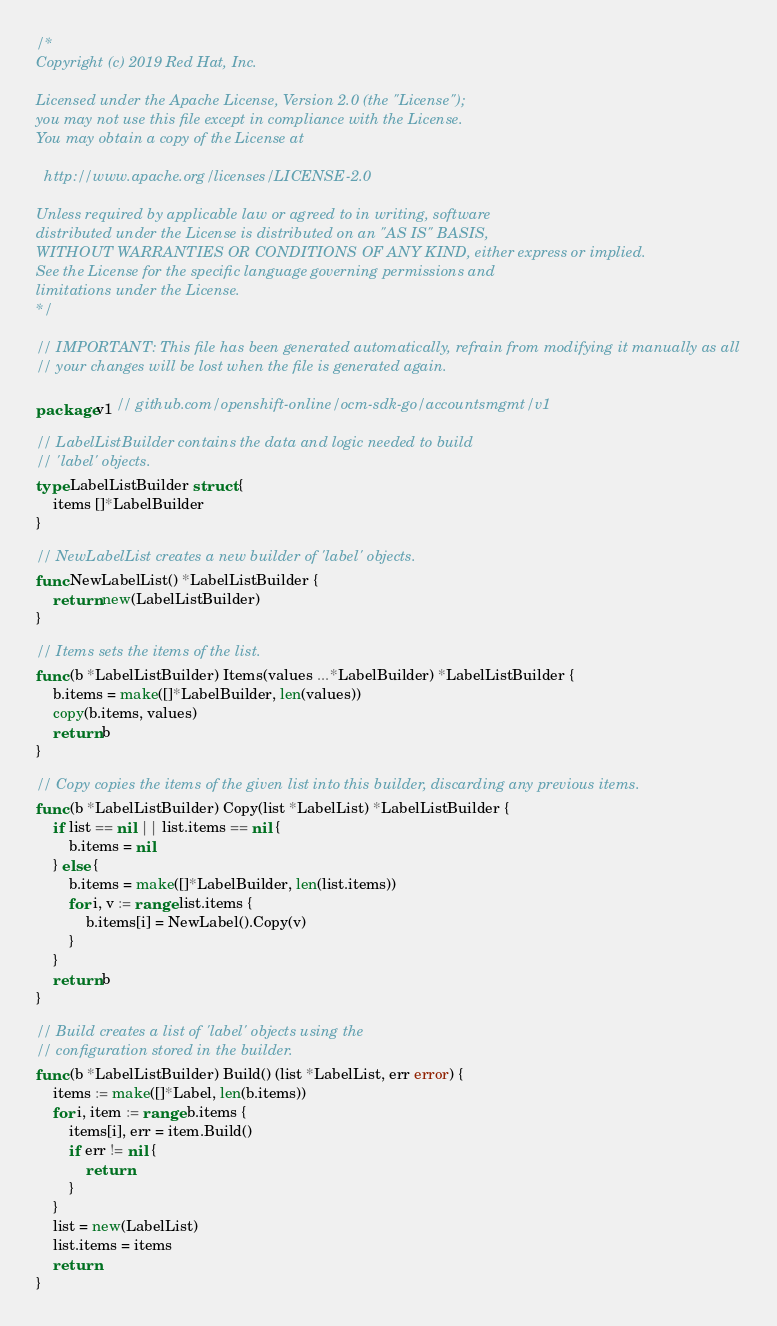Convert code to text. <code><loc_0><loc_0><loc_500><loc_500><_Go_>/*
Copyright (c) 2019 Red Hat, Inc.

Licensed under the Apache License, Version 2.0 (the "License");
you may not use this file except in compliance with the License.
You may obtain a copy of the License at

  http://www.apache.org/licenses/LICENSE-2.0

Unless required by applicable law or agreed to in writing, software
distributed under the License is distributed on an "AS IS" BASIS,
WITHOUT WARRANTIES OR CONDITIONS OF ANY KIND, either express or implied.
See the License for the specific language governing permissions and
limitations under the License.
*/

// IMPORTANT: This file has been generated automatically, refrain from modifying it manually as all
// your changes will be lost when the file is generated again.

package v1 // github.com/openshift-online/ocm-sdk-go/accountsmgmt/v1

// LabelListBuilder contains the data and logic needed to build
// 'label' objects.
type LabelListBuilder struct {
	items []*LabelBuilder
}

// NewLabelList creates a new builder of 'label' objects.
func NewLabelList() *LabelListBuilder {
	return new(LabelListBuilder)
}

// Items sets the items of the list.
func (b *LabelListBuilder) Items(values ...*LabelBuilder) *LabelListBuilder {
	b.items = make([]*LabelBuilder, len(values))
	copy(b.items, values)
	return b
}

// Copy copies the items of the given list into this builder, discarding any previous items.
func (b *LabelListBuilder) Copy(list *LabelList) *LabelListBuilder {
	if list == nil || list.items == nil {
		b.items = nil
	} else {
		b.items = make([]*LabelBuilder, len(list.items))
		for i, v := range list.items {
			b.items[i] = NewLabel().Copy(v)
		}
	}
	return b
}

// Build creates a list of 'label' objects using the
// configuration stored in the builder.
func (b *LabelListBuilder) Build() (list *LabelList, err error) {
	items := make([]*Label, len(b.items))
	for i, item := range b.items {
		items[i], err = item.Build()
		if err != nil {
			return
		}
	}
	list = new(LabelList)
	list.items = items
	return
}
</code> 